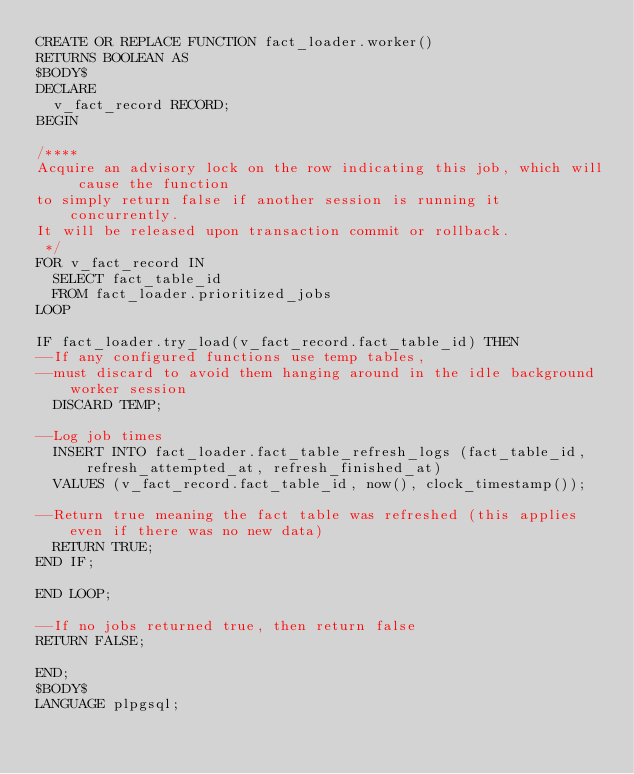Convert code to text. <code><loc_0><loc_0><loc_500><loc_500><_SQL_>CREATE OR REPLACE FUNCTION fact_loader.worker()
RETURNS BOOLEAN AS
$BODY$
DECLARE
  v_fact_record RECORD;
BEGIN

/****
Acquire an advisory lock on the row indicating this job, which will cause the function
to simply return false if another session is running it concurrently.
It will be released upon transaction commit or rollback.
 */
FOR v_fact_record IN
  SELECT fact_table_id
  FROM fact_loader.prioritized_jobs
LOOP

IF fact_loader.try_load(v_fact_record.fact_table_id) THEN
--If any configured functions use temp tables,
--must discard to avoid them hanging around in the idle background worker session
  DISCARD TEMP;

--Log job times
  INSERT INTO fact_loader.fact_table_refresh_logs (fact_table_id, refresh_attempted_at, refresh_finished_at)
  VALUES (v_fact_record.fact_table_id, now(), clock_timestamp());

--Return true meaning the fact table was refreshed (this applies even if there was no new data)
  RETURN TRUE;
END IF;

END LOOP;

--If no jobs returned true, then return false
RETURN FALSE;

END;
$BODY$
LANGUAGE plpgsql;
</code> 